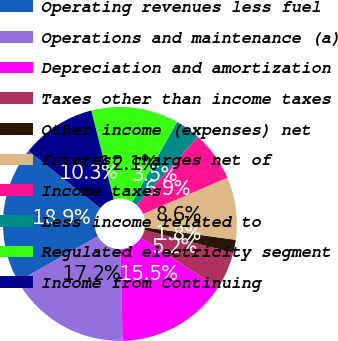Convert chart to OTSL. <chart><loc_0><loc_0><loc_500><loc_500><pie_chart><fcel>Operating revenues less fuel<fcel>Operations and maintenance (a)<fcel>Depreciation and amortization<fcel>Taxes other than income taxes<fcel>Other income (expenses) net<fcel>Interest charges net of<fcel>Income taxes<fcel>Less income related to<fcel>Regulated electricity segment<fcel>Income from Continuing<nl><fcel>18.89%<fcel>17.18%<fcel>15.47%<fcel>5.21%<fcel>1.79%<fcel>8.63%<fcel>6.92%<fcel>3.5%<fcel>12.05%<fcel>10.34%<nl></chart> 